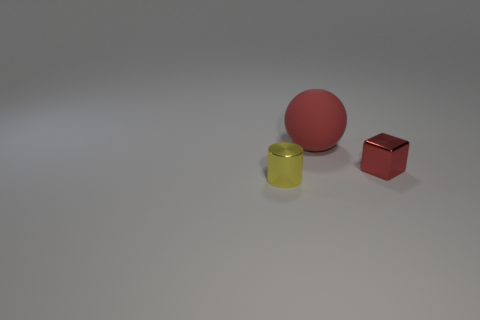How many red things are large balls or large cubes?
Your response must be concise. 1. What size is the shiny object that is the same color as the large rubber ball?
Make the answer very short. Small. Is the number of small red metallic things greater than the number of objects?
Make the answer very short. No. Do the large ball and the cylinder have the same color?
Ensure brevity in your answer.  No. How many things are cylinders or objects on the right side of the big red sphere?
Ensure brevity in your answer.  2. How many other things are there of the same shape as the small red shiny object?
Provide a succinct answer. 0. Are there fewer big red rubber things that are to the left of the cylinder than red blocks that are behind the small red shiny thing?
Provide a succinct answer. No. Is there anything else that is the same material as the yellow cylinder?
Provide a short and direct response. Yes. The tiny thing that is the same material as the yellow cylinder is what shape?
Provide a short and direct response. Cube. Is there anything else that is the same color as the cylinder?
Offer a terse response. No. 